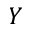Convert formula to latex. <formula><loc_0><loc_0><loc_500><loc_500>Y</formula> 